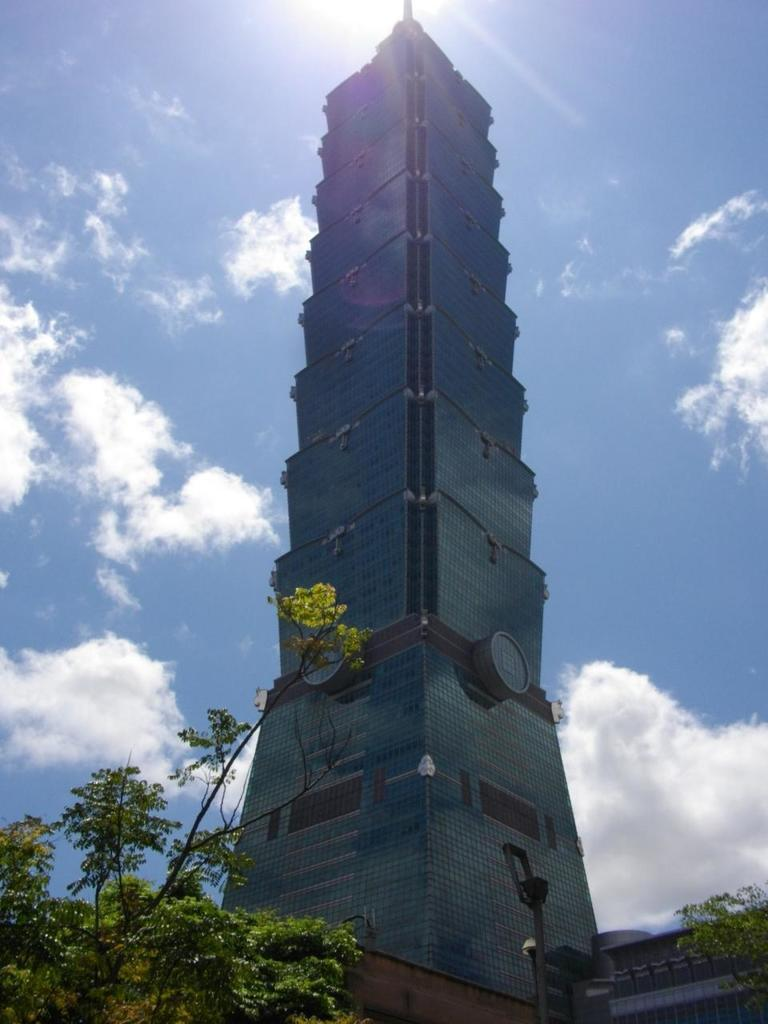What type of structure is visible in the image? There is a building in the image. What natural elements can be seen at the bottom of the image? Trees are present at the bottom of the image. What object is located at the bottom of the image, near the trees? There is a pole at the bottom of the image. What can be seen in the background of the image? The sky is visible in the background of the image. How many pins are attached to the baby's clothing in the image? There is no baby or pins present in the image. 